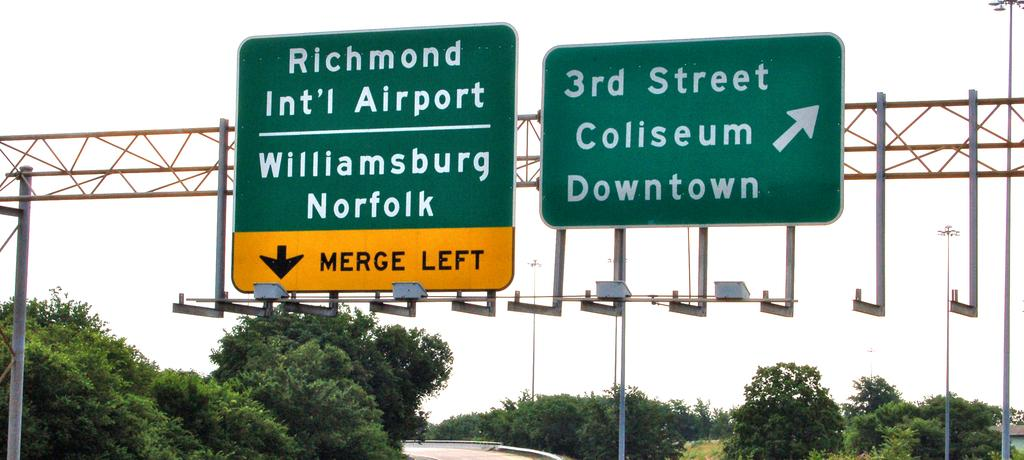<image>
Offer a succinct explanation of the picture presented. A sign tells people they have to merge left to get to the airport. 